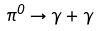<formula> <loc_0><loc_0><loc_500><loc_500>\pi ^ { 0 } \rightarrow \gamma + \gamma</formula> 